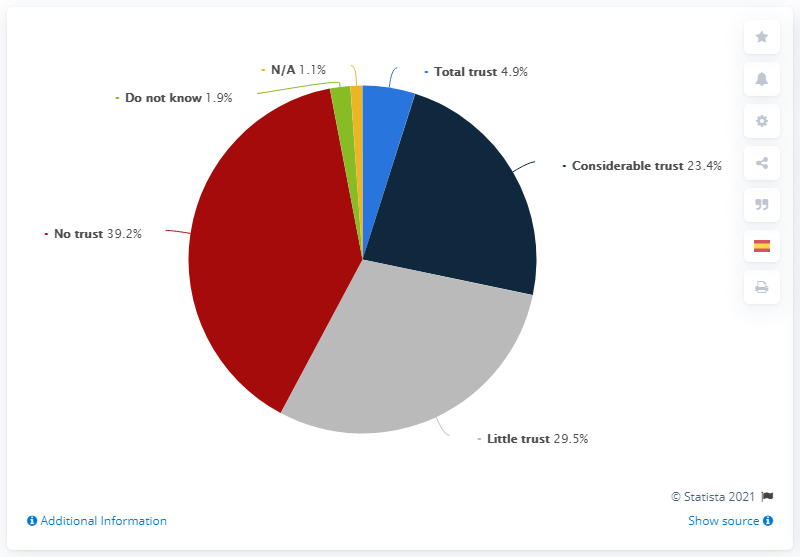Outline some significant characteristics in this image. The largest portion of the graph is red in color. The sum of the highest and lowest percentage in the chart is 40.3%. 